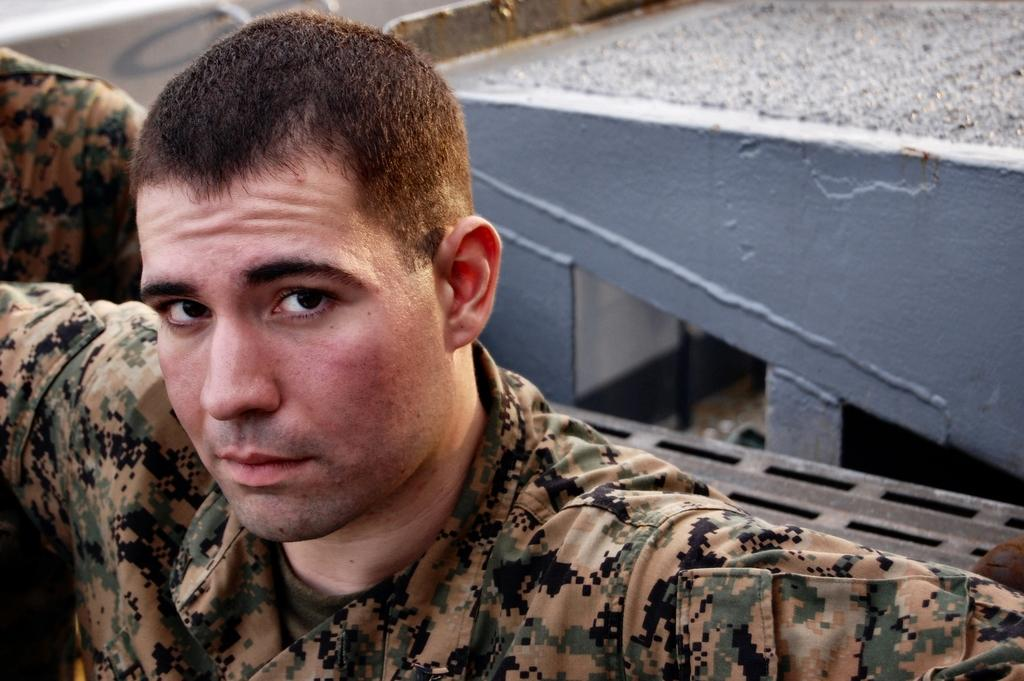What is the person in the foreground of the image wearing? The person in the image is wearing an army uniform. Can you describe the background of the image? There is another person and an object in the background of the image. What is the second person doing in the background? The facts provided do not specify what the second person is doing in the background. What type of waves can be seen in the image? There are no waves present in the image. 